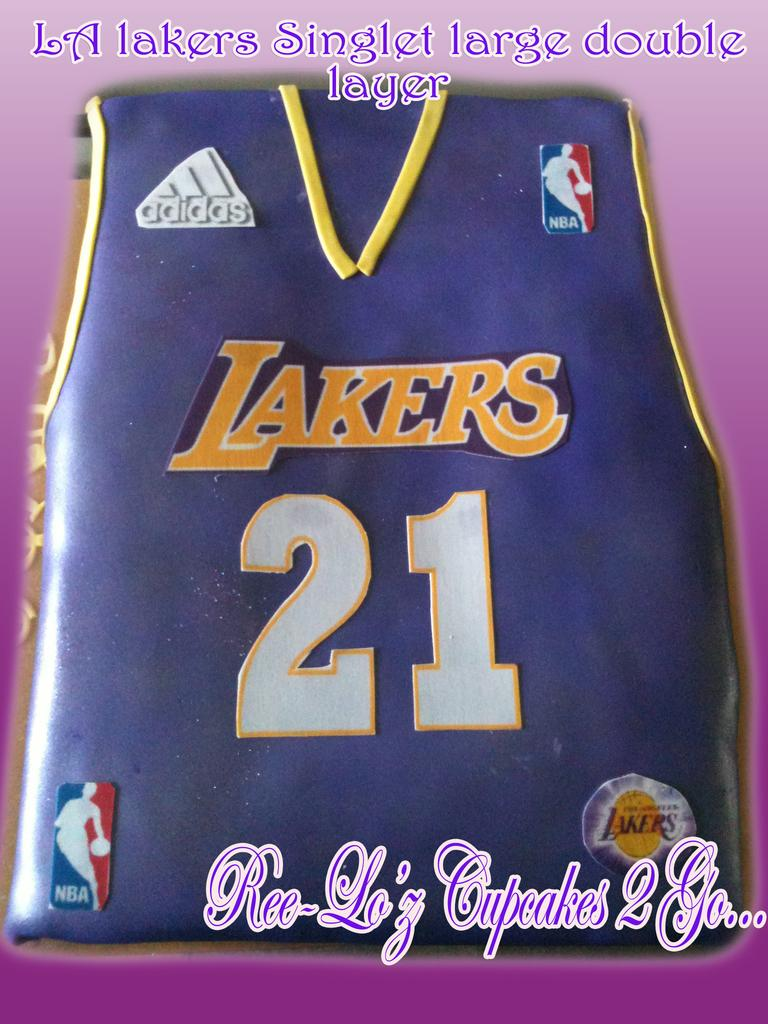<image>
Relay a brief, clear account of the picture shown. A cake made to resemble an L.A. Lakers basketball jersey. 